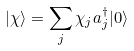<formula> <loc_0><loc_0><loc_500><loc_500>| \chi \rangle = \sum _ { j } \chi _ { j } a _ { j } ^ { \dagger } | 0 \rangle</formula> 